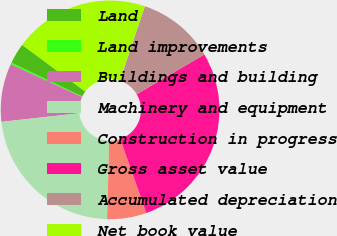Convert chart to OTSL. <chart><loc_0><loc_0><loc_500><loc_500><pie_chart><fcel>Land<fcel>Land improvements<fcel>Buildings and building<fcel>Machinery and equipment<fcel>Construction in progress<fcel>Gross asset value<fcel>Accumulated depreciation<fcel>Net book value<nl><fcel>3.03%<fcel>0.25%<fcel>8.6%<fcel>22.81%<fcel>5.82%<fcel>28.08%<fcel>11.38%<fcel>20.02%<nl></chart> 